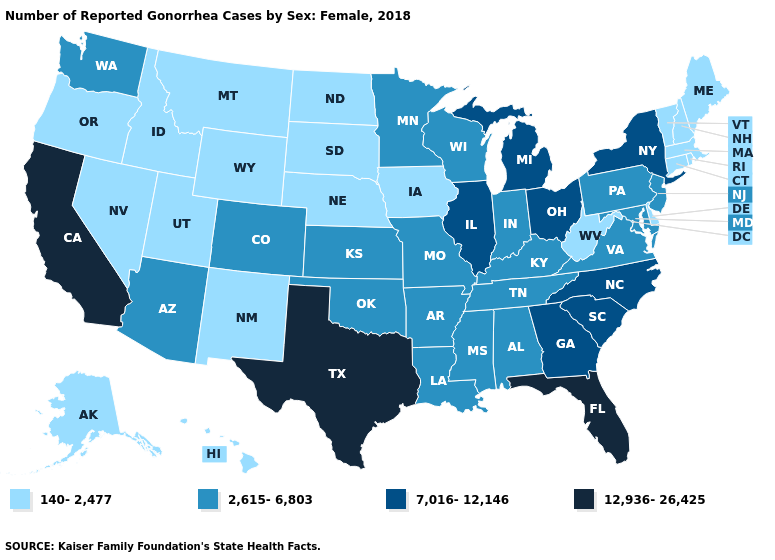What is the value of Massachusetts?
Answer briefly. 140-2,477. Name the states that have a value in the range 140-2,477?
Write a very short answer. Alaska, Connecticut, Delaware, Hawaii, Idaho, Iowa, Maine, Massachusetts, Montana, Nebraska, Nevada, New Hampshire, New Mexico, North Dakota, Oregon, Rhode Island, South Dakota, Utah, Vermont, West Virginia, Wyoming. What is the value of California?
Concise answer only. 12,936-26,425. What is the value of Hawaii?
Answer briefly. 140-2,477. Does the map have missing data?
Write a very short answer. No. Does Minnesota have a lower value than Delaware?
Give a very brief answer. No. What is the value of Wyoming?
Quick response, please. 140-2,477. Does Utah have the same value as Iowa?
Be succinct. Yes. What is the value of Kansas?
Short answer required. 2,615-6,803. Which states have the lowest value in the MidWest?
Give a very brief answer. Iowa, Nebraska, North Dakota, South Dakota. What is the value of Indiana?
Short answer required. 2,615-6,803. Is the legend a continuous bar?
Quick response, please. No. What is the value of Kentucky?
Give a very brief answer. 2,615-6,803. Does New Hampshire have the same value as Missouri?
Answer briefly. No. Does Missouri have the same value as Hawaii?
Answer briefly. No. 